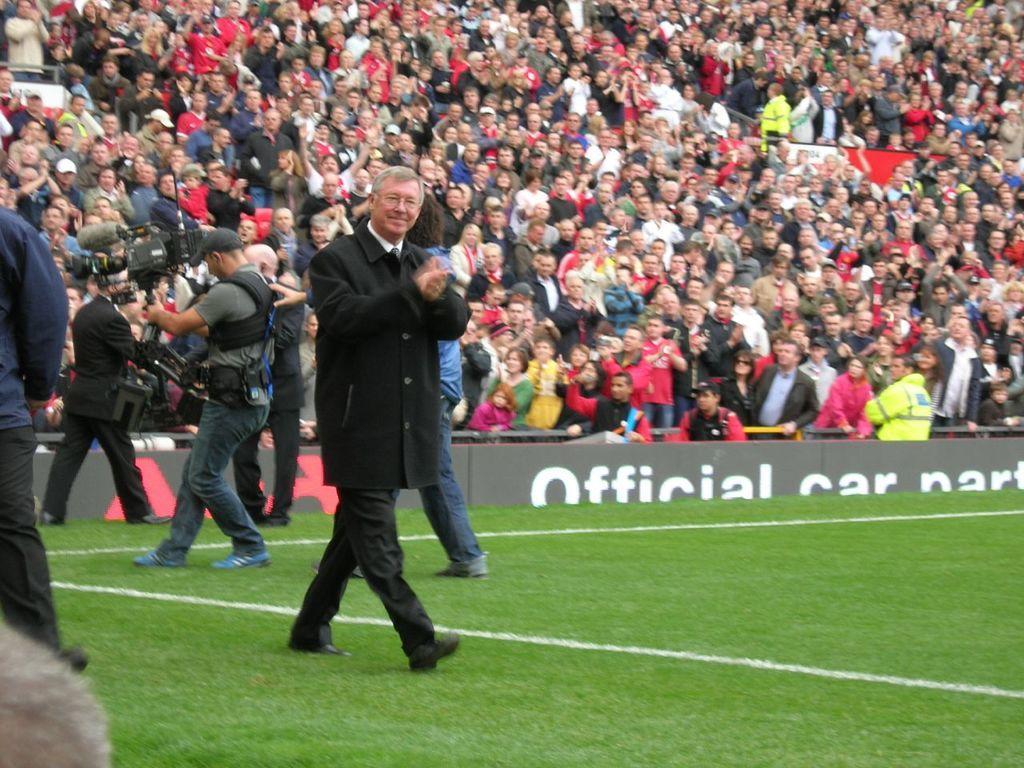Describe this image in one or two sentences. In the center of the image we can see a man walking and clapping his hands. In the background there are people sitting. On the left there is a man standing. At the bottom there is ground. 